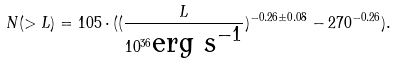Convert formula to latex. <formula><loc_0><loc_0><loc_500><loc_500>N ( > L ) = 1 0 5 \cdot ( ( \frac { L } { 1 0 ^ { 3 6 } \text {erg s$^{-1}$} } ) ^ { - 0 . 2 6 \pm 0 . 0 8 } - 2 7 0 ^ { - 0 . 2 6 } ) .</formula> 